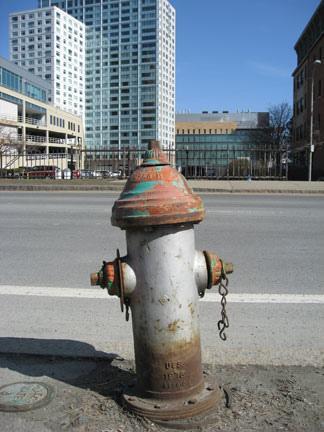How many different colors are on the fire hydrant?
Give a very brief answer. 3. How many chains are there?
Give a very brief answer. 1. How many faucets are open?
Give a very brief answer. 0. How many yellow bikes are there?
Give a very brief answer. 0. 